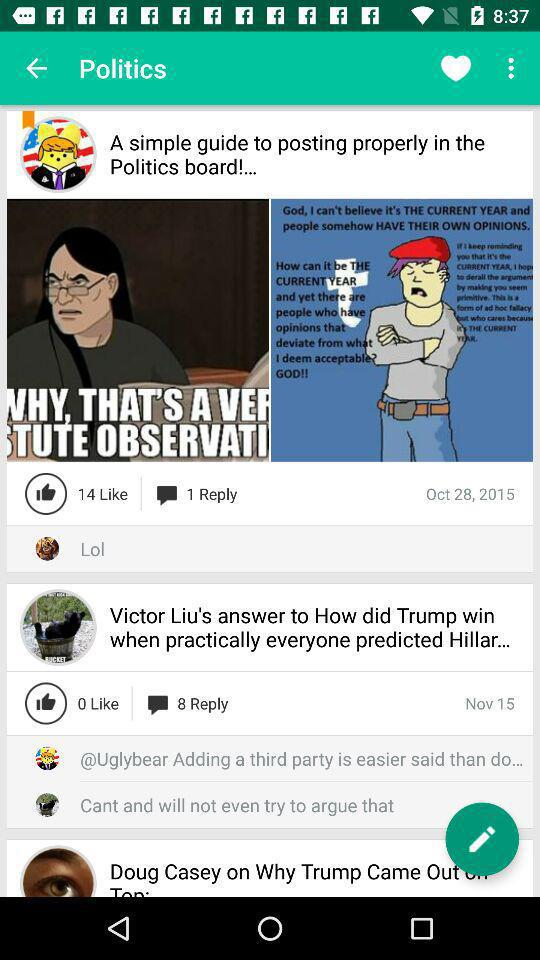How many replies on "Victor Liu's answer" post? There are 8 replies. 